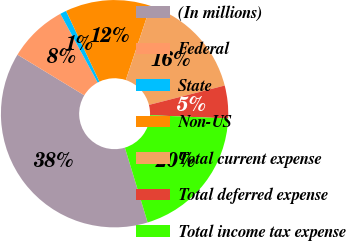Convert chart. <chart><loc_0><loc_0><loc_500><loc_500><pie_chart><fcel>(In millions)<fcel>Federal<fcel>State<fcel>Non-US<fcel>Total current expense<fcel>Total deferred expense<fcel>Total income tax expense<nl><fcel>38.39%<fcel>8.39%<fcel>0.9%<fcel>12.14%<fcel>15.89%<fcel>4.65%<fcel>19.64%<nl></chart> 